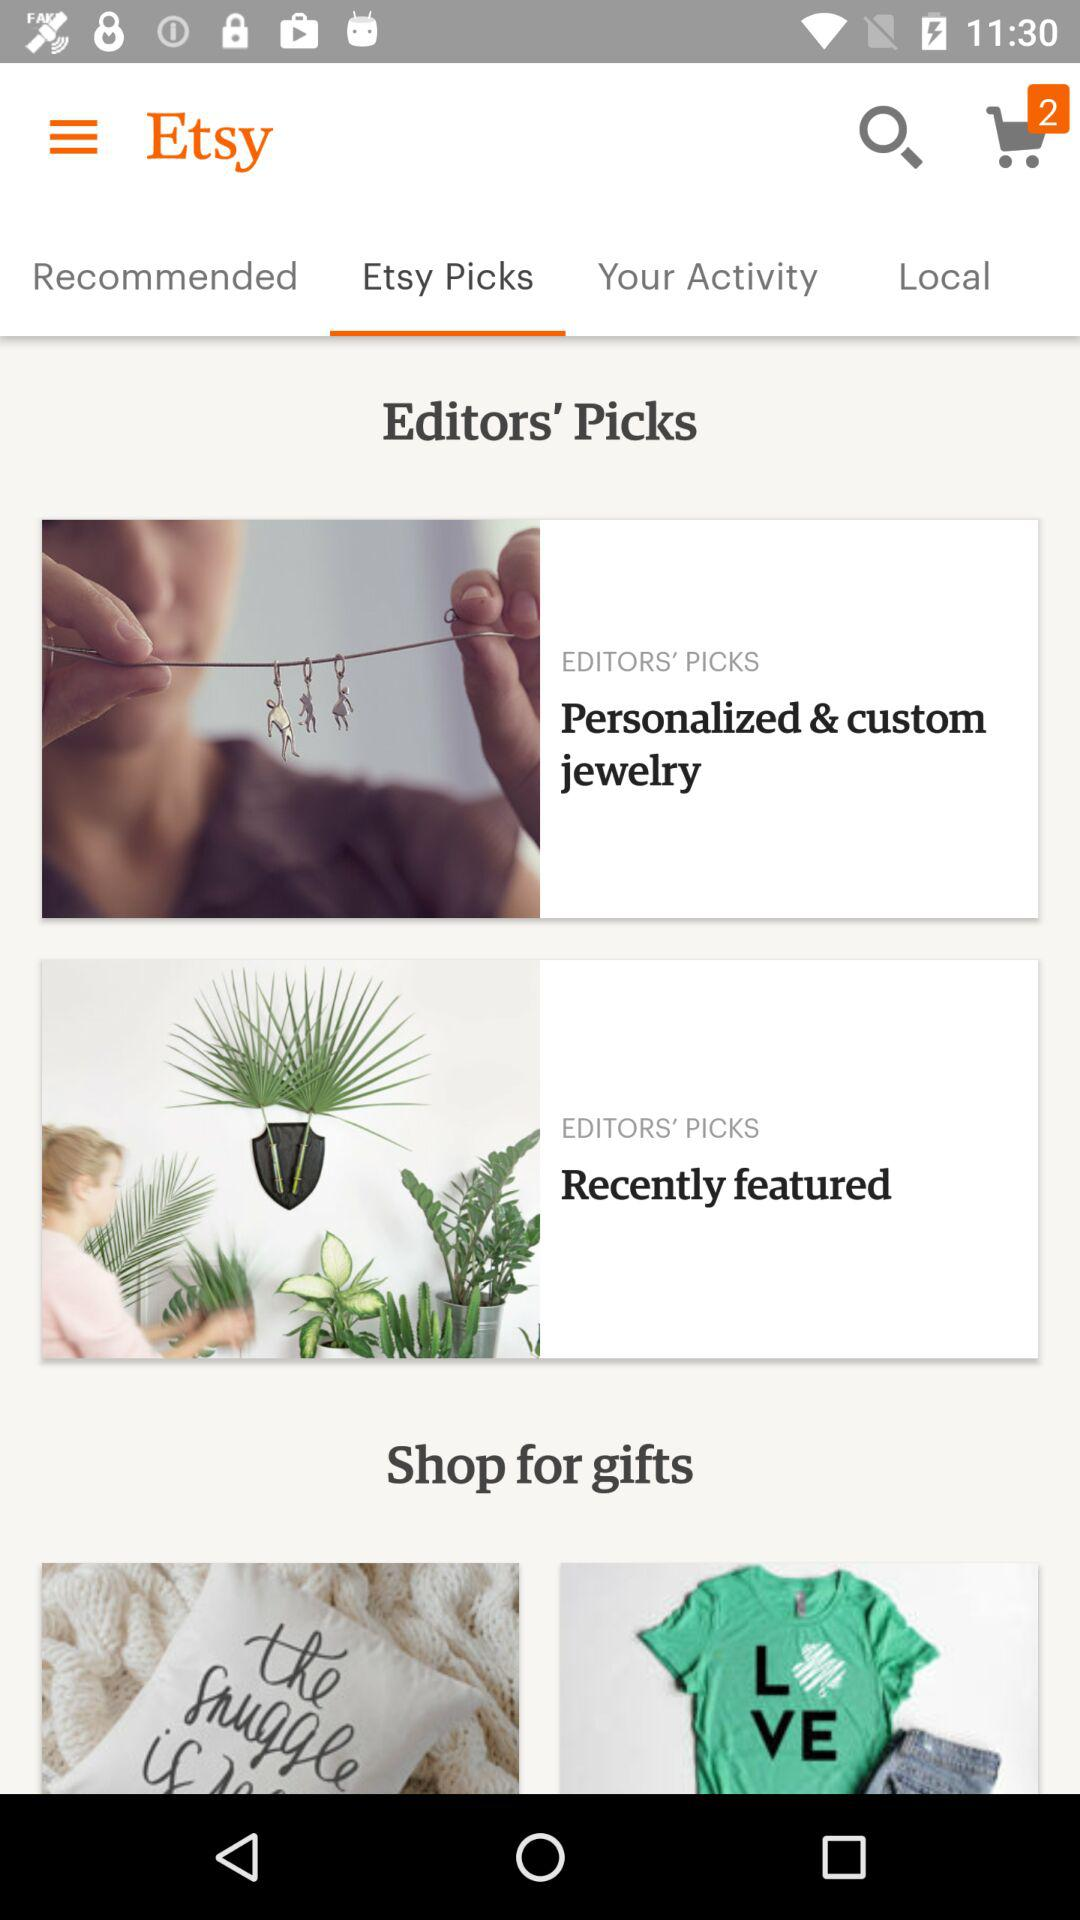How many more Etsy Picks items are there than Local items?
Answer the question using a single word or phrase. 2 